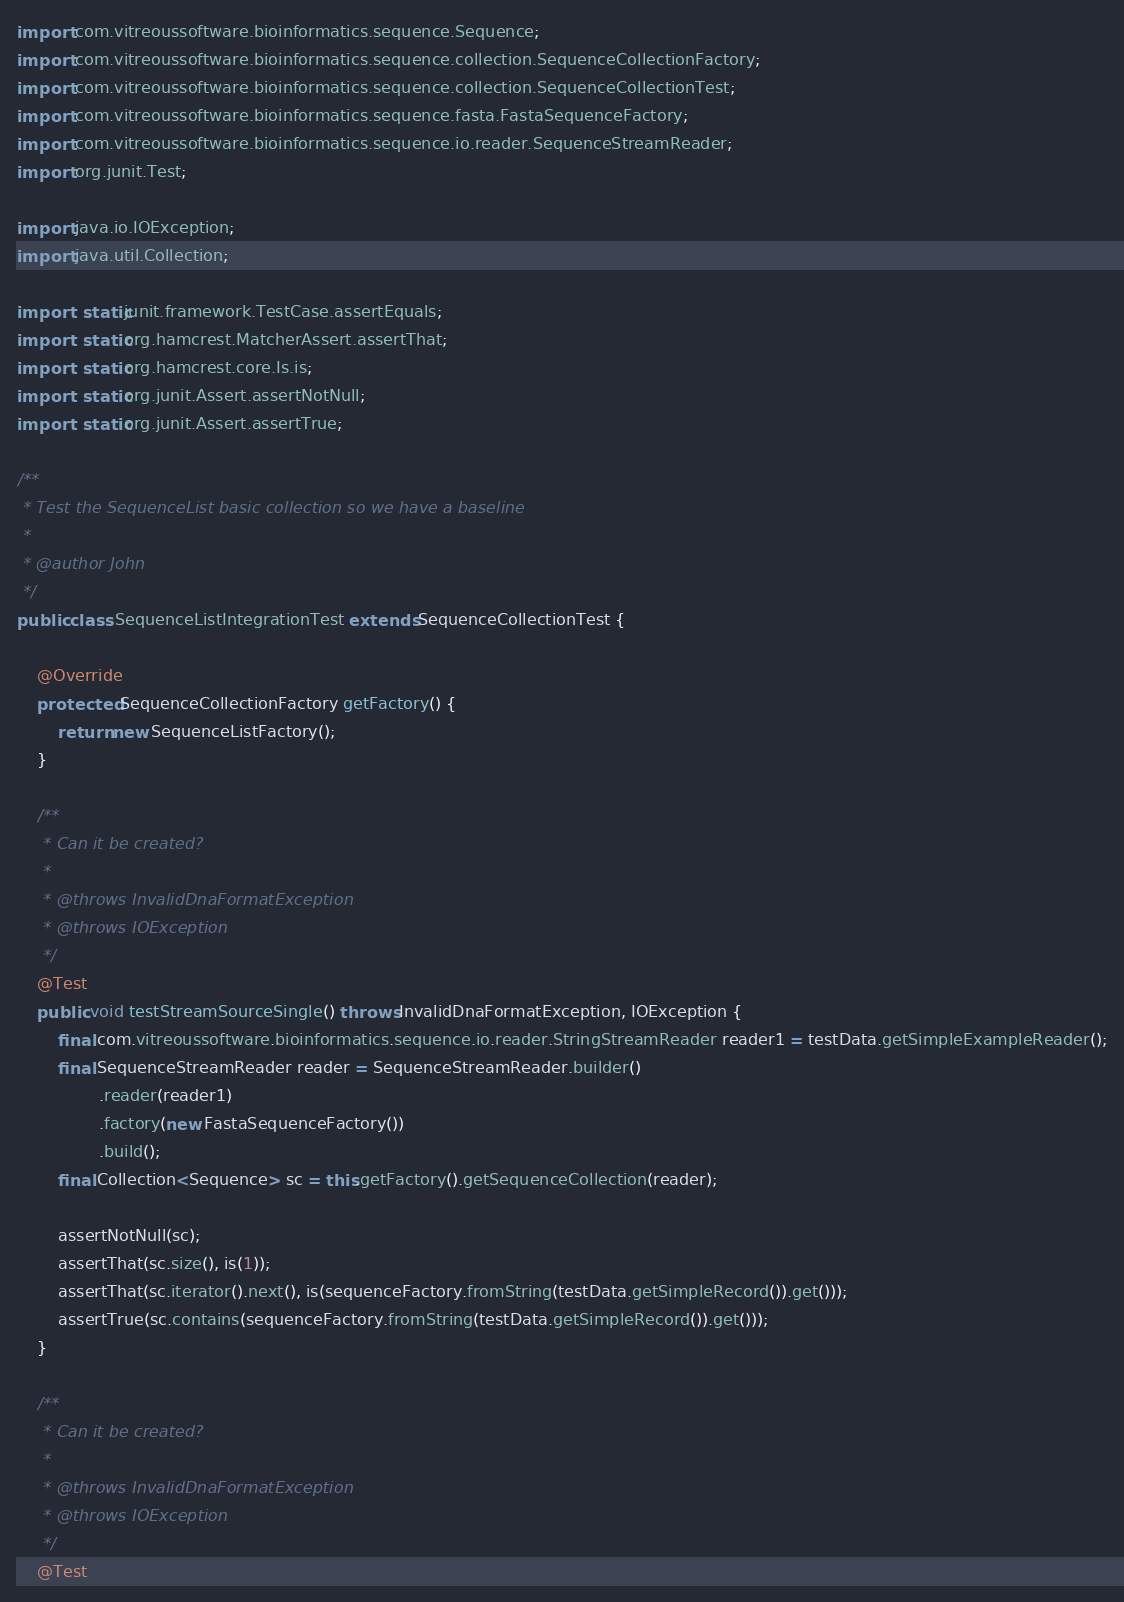Convert code to text. <code><loc_0><loc_0><loc_500><loc_500><_Java_>import com.vitreoussoftware.bioinformatics.sequence.Sequence;
import com.vitreoussoftware.bioinformatics.sequence.collection.SequenceCollectionFactory;
import com.vitreoussoftware.bioinformatics.sequence.collection.SequenceCollectionTest;
import com.vitreoussoftware.bioinformatics.sequence.fasta.FastaSequenceFactory;
import com.vitreoussoftware.bioinformatics.sequence.io.reader.SequenceStreamReader;
import org.junit.Test;

import java.io.IOException;
import java.util.Collection;

import static junit.framework.TestCase.assertEquals;
import static org.hamcrest.MatcherAssert.assertThat;
import static org.hamcrest.core.Is.is;
import static org.junit.Assert.assertNotNull;
import static org.junit.Assert.assertTrue;

/**
 * Test the SequenceList basic collection so we have a baseline
 *
 * @author John
 */
public class SequenceListIntegrationTest extends SequenceCollectionTest {

    @Override
    protected SequenceCollectionFactory getFactory() {
        return new SequenceListFactory();
    }

    /**
     * Can it be created?
     *
     * @throws InvalidDnaFormatException
     * @throws IOException
     */
    @Test
    public void testStreamSourceSingle() throws InvalidDnaFormatException, IOException {
        final com.vitreoussoftware.bioinformatics.sequence.io.reader.StringStreamReader reader1 = testData.getSimpleExampleReader();
        final SequenceStreamReader reader = SequenceStreamReader.builder()
                .reader(reader1)
                .factory(new FastaSequenceFactory())
                .build();
        final Collection<Sequence> sc = this.getFactory().getSequenceCollection(reader);

        assertNotNull(sc);
        assertThat(sc.size(), is(1));
        assertThat(sc.iterator().next(), is(sequenceFactory.fromString(testData.getSimpleRecord()).get()));
        assertTrue(sc.contains(sequenceFactory.fromString(testData.getSimpleRecord()).get()));
    }

    /**
     * Can it be created?
     *
     * @throws InvalidDnaFormatException
     * @throws IOException
     */
    @Test</code> 